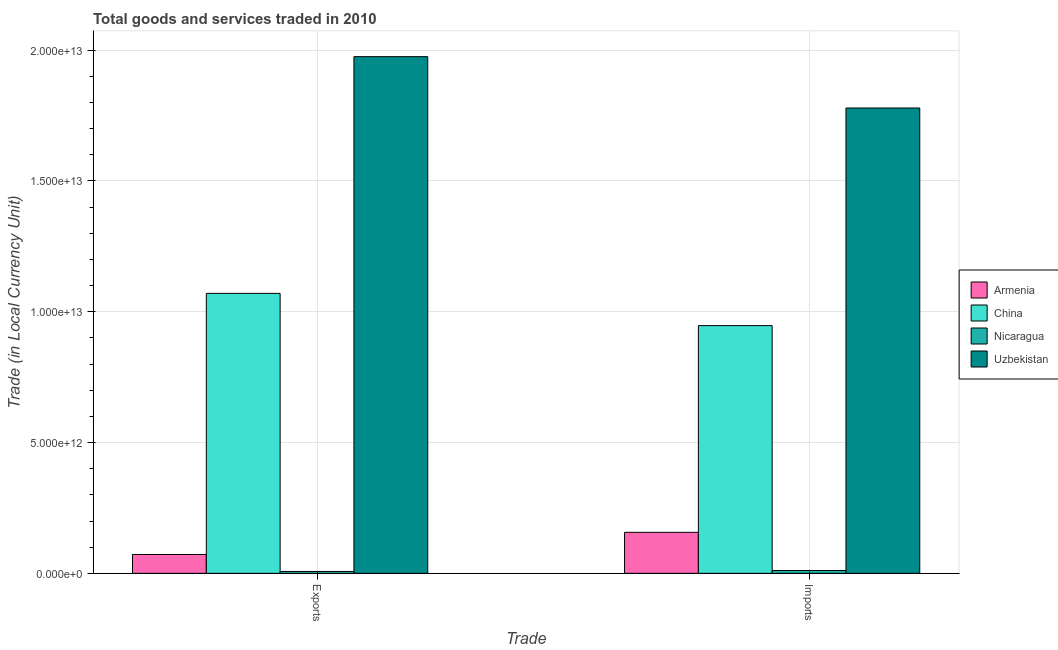How many different coloured bars are there?
Offer a very short reply. 4. Are the number of bars per tick equal to the number of legend labels?
Offer a terse response. Yes. Are the number of bars on each tick of the X-axis equal?
Your response must be concise. Yes. What is the label of the 2nd group of bars from the left?
Make the answer very short. Imports. What is the export of goods and services in Nicaragua?
Your answer should be very brief. 7.18e+1. Across all countries, what is the maximum imports of goods and services?
Keep it short and to the point. 1.78e+13. Across all countries, what is the minimum imports of goods and services?
Give a very brief answer. 1.08e+11. In which country was the imports of goods and services maximum?
Your answer should be compact. Uzbekistan. In which country was the export of goods and services minimum?
Offer a terse response. Nicaragua. What is the total imports of goods and services in the graph?
Your answer should be compact. 2.89e+13. What is the difference between the imports of goods and services in Uzbekistan and that in China?
Your response must be concise. 8.32e+12. What is the difference between the export of goods and services in China and the imports of goods and services in Nicaragua?
Your answer should be very brief. 1.06e+13. What is the average imports of goods and services per country?
Your response must be concise. 7.23e+12. What is the difference between the export of goods and services and imports of goods and services in Armenia?
Make the answer very short. -8.47e+11. What is the ratio of the export of goods and services in China to that in Nicaragua?
Give a very brief answer. 149.1. What does the 1st bar from the left in Imports represents?
Offer a very short reply. Armenia. What does the 3rd bar from the right in Imports represents?
Give a very brief answer. China. How many bars are there?
Offer a very short reply. 8. Are all the bars in the graph horizontal?
Give a very brief answer. No. What is the difference between two consecutive major ticks on the Y-axis?
Provide a succinct answer. 5.00e+12. How are the legend labels stacked?
Keep it short and to the point. Vertical. What is the title of the graph?
Keep it short and to the point. Total goods and services traded in 2010. What is the label or title of the X-axis?
Provide a short and direct response. Trade. What is the label or title of the Y-axis?
Provide a succinct answer. Trade (in Local Currency Unit). What is the Trade (in Local Currency Unit) in Armenia in Exports?
Make the answer very short. 7.21e+11. What is the Trade (in Local Currency Unit) of China in Exports?
Make the answer very short. 1.07e+13. What is the Trade (in Local Currency Unit) of Nicaragua in Exports?
Make the answer very short. 7.18e+1. What is the Trade (in Local Currency Unit) in Uzbekistan in Exports?
Your response must be concise. 1.98e+13. What is the Trade (in Local Currency Unit) in Armenia in Imports?
Offer a terse response. 1.57e+12. What is the Trade (in Local Currency Unit) in China in Imports?
Ensure brevity in your answer.  9.47e+12. What is the Trade (in Local Currency Unit) in Nicaragua in Imports?
Keep it short and to the point. 1.08e+11. What is the Trade (in Local Currency Unit) in Uzbekistan in Imports?
Your response must be concise. 1.78e+13. Across all Trade, what is the maximum Trade (in Local Currency Unit) in Armenia?
Provide a short and direct response. 1.57e+12. Across all Trade, what is the maximum Trade (in Local Currency Unit) of China?
Provide a short and direct response. 1.07e+13. Across all Trade, what is the maximum Trade (in Local Currency Unit) of Nicaragua?
Your answer should be compact. 1.08e+11. Across all Trade, what is the maximum Trade (in Local Currency Unit) of Uzbekistan?
Make the answer very short. 1.98e+13. Across all Trade, what is the minimum Trade (in Local Currency Unit) in Armenia?
Keep it short and to the point. 7.21e+11. Across all Trade, what is the minimum Trade (in Local Currency Unit) of China?
Keep it short and to the point. 9.47e+12. Across all Trade, what is the minimum Trade (in Local Currency Unit) in Nicaragua?
Your answer should be very brief. 7.18e+1. Across all Trade, what is the minimum Trade (in Local Currency Unit) in Uzbekistan?
Keep it short and to the point. 1.78e+13. What is the total Trade (in Local Currency Unit) of Armenia in the graph?
Your answer should be very brief. 2.29e+12. What is the total Trade (in Local Currency Unit) of China in the graph?
Your response must be concise. 2.02e+13. What is the total Trade (in Local Currency Unit) in Nicaragua in the graph?
Your answer should be compact. 1.80e+11. What is the total Trade (in Local Currency Unit) of Uzbekistan in the graph?
Provide a short and direct response. 3.75e+13. What is the difference between the Trade (in Local Currency Unit) of Armenia in Exports and that in Imports?
Ensure brevity in your answer.  -8.47e+11. What is the difference between the Trade (in Local Currency Unit) of China in Exports and that in Imports?
Keep it short and to the point. 1.23e+12. What is the difference between the Trade (in Local Currency Unit) of Nicaragua in Exports and that in Imports?
Provide a succinct answer. -3.64e+1. What is the difference between the Trade (in Local Currency Unit) of Uzbekistan in Exports and that in Imports?
Offer a very short reply. 1.96e+12. What is the difference between the Trade (in Local Currency Unit) in Armenia in Exports and the Trade (in Local Currency Unit) in China in Imports?
Offer a very short reply. -8.75e+12. What is the difference between the Trade (in Local Currency Unit) in Armenia in Exports and the Trade (in Local Currency Unit) in Nicaragua in Imports?
Make the answer very short. 6.13e+11. What is the difference between the Trade (in Local Currency Unit) of Armenia in Exports and the Trade (in Local Currency Unit) of Uzbekistan in Imports?
Provide a succinct answer. -1.71e+13. What is the difference between the Trade (in Local Currency Unit) in China in Exports and the Trade (in Local Currency Unit) in Nicaragua in Imports?
Provide a short and direct response. 1.06e+13. What is the difference between the Trade (in Local Currency Unit) of China in Exports and the Trade (in Local Currency Unit) of Uzbekistan in Imports?
Your answer should be compact. -7.09e+12. What is the difference between the Trade (in Local Currency Unit) in Nicaragua in Exports and the Trade (in Local Currency Unit) in Uzbekistan in Imports?
Your response must be concise. -1.77e+13. What is the average Trade (in Local Currency Unit) of Armenia per Trade?
Give a very brief answer. 1.14e+12. What is the average Trade (in Local Currency Unit) in China per Trade?
Offer a terse response. 1.01e+13. What is the average Trade (in Local Currency Unit) of Nicaragua per Trade?
Offer a very short reply. 9.00e+1. What is the average Trade (in Local Currency Unit) in Uzbekistan per Trade?
Your response must be concise. 1.88e+13. What is the difference between the Trade (in Local Currency Unit) of Armenia and Trade (in Local Currency Unit) of China in Exports?
Ensure brevity in your answer.  -9.98e+12. What is the difference between the Trade (in Local Currency Unit) in Armenia and Trade (in Local Currency Unit) in Nicaragua in Exports?
Your answer should be very brief. 6.49e+11. What is the difference between the Trade (in Local Currency Unit) in Armenia and Trade (in Local Currency Unit) in Uzbekistan in Exports?
Offer a terse response. -1.90e+13. What is the difference between the Trade (in Local Currency Unit) in China and Trade (in Local Currency Unit) in Nicaragua in Exports?
Your answer should be compact. 1.06e+13. What is the difference between the Trade (in Local Currency Unit) in China and Trade (in Local Currency Unit) in Uzbekistan in Exports?
Provide a short and direct response. -9.05e+12. What is the difference between the Trade (in Local Currency Unit) in Nicaragua and Trade (in Local Currency Unit) in Uzbekistan in Exports?
Offer a very short reply. -1.97e+13. What is the difference between the Trade (in Local Currency Unit) of Armenia and Trade (in Local Currency Unit) of China in Imports?
Keep it short and to the point. -7.90e+12. What is the difference between the Trade (in Local Currency Unit) in Armenia and Trade (in Local Currency Unit) in Nicaragua in Imports?
Your answer should be compact. 1.46e+12. What is the difference between the Trade (in Local Currency Unit) of Armenia and Trade (in Local Currency Unit) of Uzbekistan in Imports?
Your answer should be very brief. -1.62e+13. What is the difference between the Trade (in Local Currency Unit) in China and Trade (in Local Currency Unit) in Nicaragua in Imports?
Make the answer very short. 9.36e+12. What is the difference between the Trade (in Local Currency Unit) of China and Trade (in Local Currency Unit) of Uzbekistan in Imports?
Your answer should be very brief. -8.32e+12. What is the difference between the Trade (in Local Currency Unit) in Nicaragua and Trade (in Local Currency Unit) in Uzbekistan in Imports?
Keep it short and to the point. -1.77e+13. What is the ratio of the Trade (in Local Currency Unit) of Armenia in Exports to that in Imports?
Offer a terse response. 0.46. What is the ratio of the Trade (in Local Currency Unit) of China in Exports to that in Imports?
Make the answer very short. 1.13. What is the ratio of the Trade (in Local Currency Unit) of Nicaragua in Exports to that in Imports?
Provide a short and direct response. 0.66. What is the ratio of the Trade (in Local Currency Unit) of Uzbekistan in Exports to that in Imports?
Ensure brevity in your answer.  1.11. What is the difference between the highest and the second highest Trade (in Local Currency Unit) of Armenia?
Give a very brief answer. 8.47e+11. What is the difference between the highest and the second highest Trade (in Local Currency Unit) of China?
Your answer should be compact. 1.23e+12. What is the difference between the highest and the second highest Trade (in Local Currency Unit) in Nicaragua?
Offer a terse response. 3.64e+1. What is the difference between the highest and the second highest Trade (in Local Currency Unit) in Uzbekistan?
Give a very brief answer. 1.96e+12. What is the difference between the highest and the lowest Trade (in Local Currency Unit) in Armenia?
Your response must be concise. 8.47e+11. What is the difference between the highest and the lowest Trade (in Local Currency Unit) in China?
Make the answer very short. 1.23e+12. What is the difference between the highest and the lowest Trade (in Local Currency Unit) of Nicaragua?
Your answer should be very brief. 3.64e+1. What is the difference between the highest and the lowest Trade (in Local Currency Unit) in Uzbekistan?
Provide a short and direct response. 1.96e+12. 